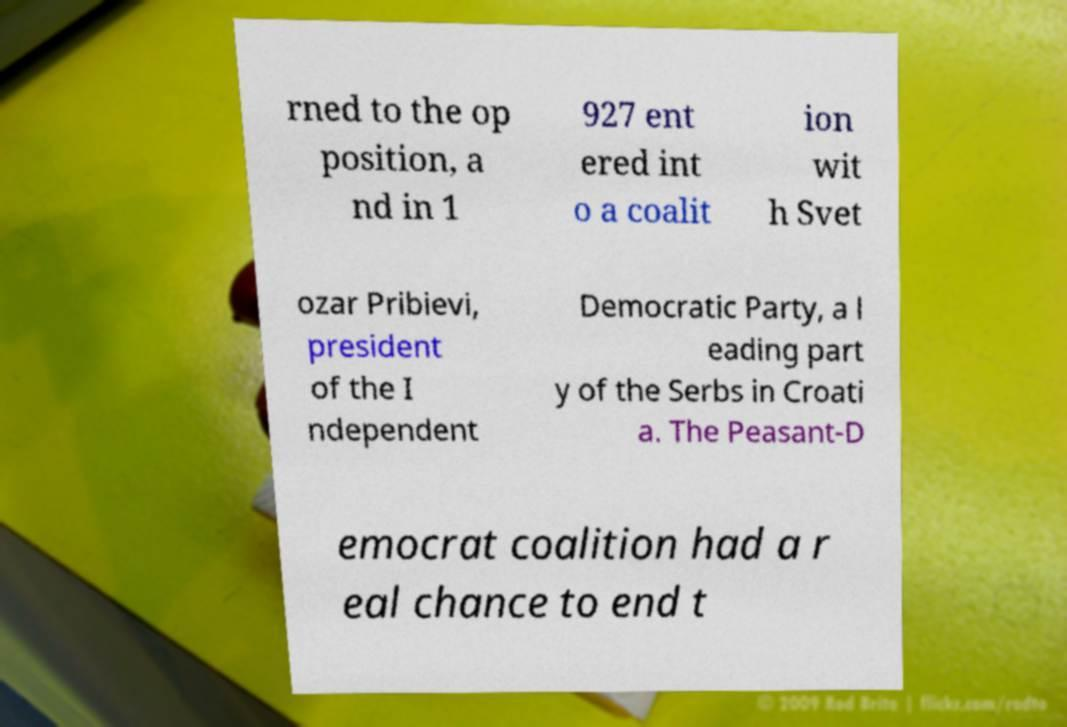For documentation purposes, I need the text within this image transcribed. Could you provide that? rned to the op position, a nd in 1 927 ent ered int o a coalit ion wit h Svet ozar Pribievi, president of the I ndependent Democratic Party, a l eading part y of the Serbs in Croati a. The Peasant-D emocrat coalition had a r eal chance to end t 